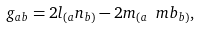<formula> <loc_0><loc_0><loc_500><loc_500>g _ { a b } = 2 l _ { ( a } n _ { b ) } - 2 m _ { ( a } \ m b _ { b ) } ,</formula> 